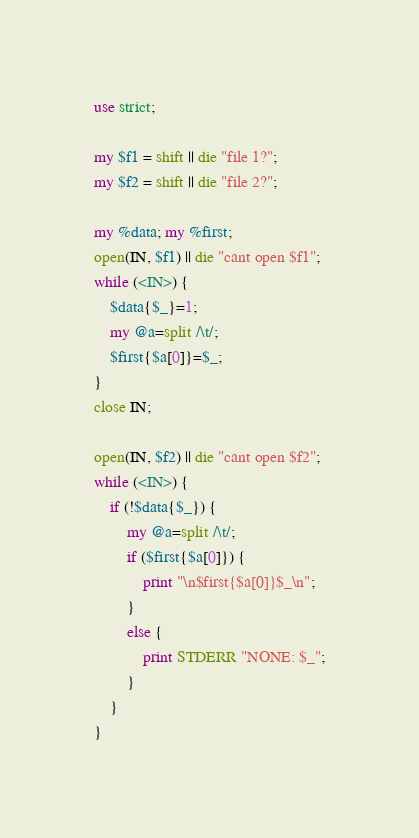Convert code to text. <code><loc_0><loc_0><loc_500><loc_500><_Perl_>use strict;

my $f1 = shift || die "file 1?";
my $f2 = shift || die "file 2?";

my %data; my %first;
open(IN, $f1) || die "cant open $f1";
while (<IN>) {
	$data{$_}=1;
	my @a=split /\t/;
	$first{$a[0]}=$_;
}
close IN;

open(IN, $f2) || die "cant open $f2";
while (<IN>) {
	if (!$data{$_}) {
		my @a=split /\t/;
		if ($first{$a[0]}) {
			print "\n$first{$a[0]}$_\n";
		}
		else {
			print STDERR "NONE: $_";
		}
	}
}
</code> 